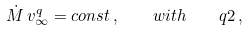<formula> <loc_0><loc_0><loc_500><loc_500>\dot { M } \, v _ { \infty } ^ { q } = c o n s t \, , \quad w i t h \quad q 2 \, ,</formula> 